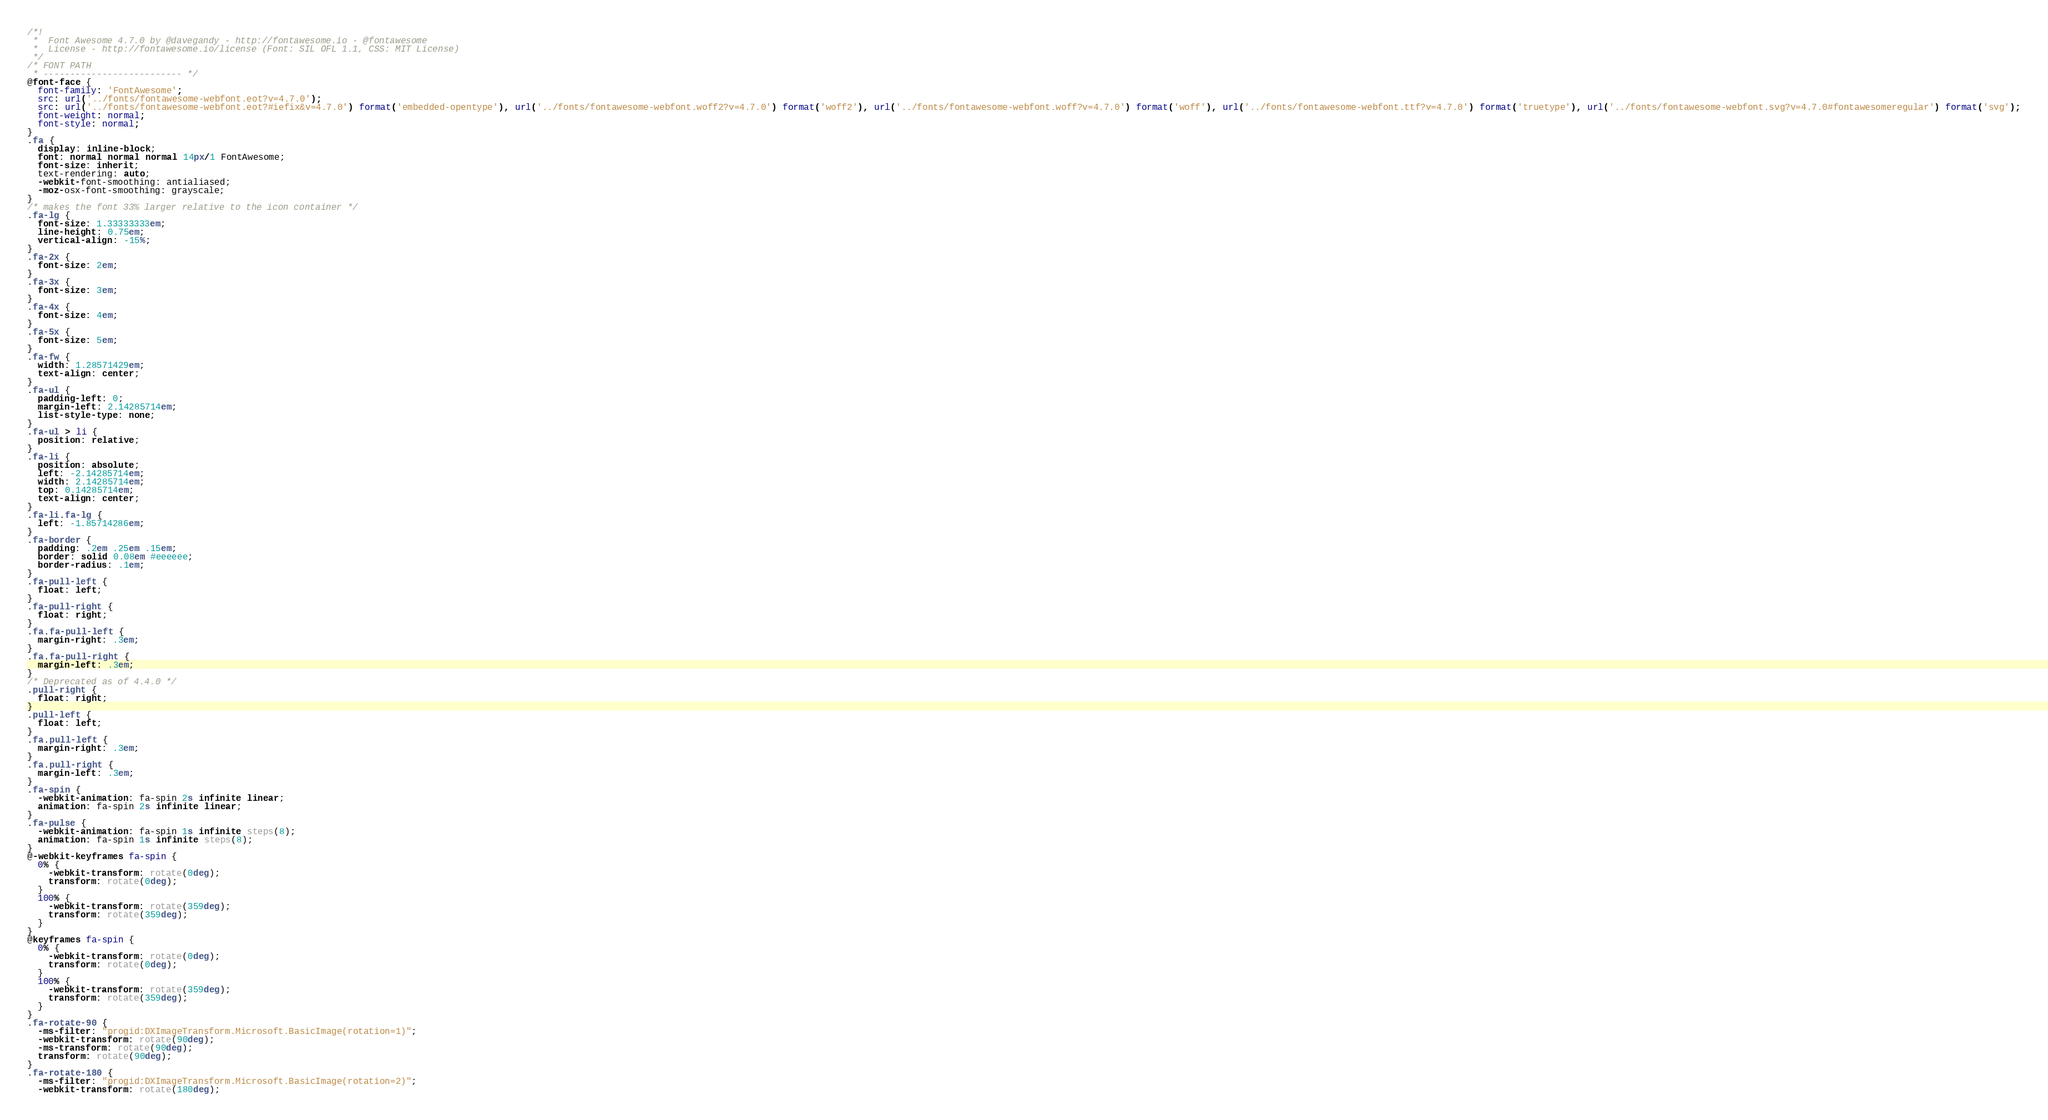<code> <loc_0><loc_0><loc_500><loc_500><_CSS_>/*!
 *  Font Awesome 4.7.0 by @davegandy - http://fontawesome.io - @fontawesome
 *  License - http://fontawesome.io/license (Font: SIL OFL 1.1, CSS: MIT License)
 */
/* FONT PATH
 * -------------------------- */
@font-face {
  font-family: 'FontAwesome';
  src: url('../fonts/fontawesome-webfont.eot?v=4.7.0');
  src: url('../fonts/fontawesome-webfont.eot?#iefix&v=4.7.0') format('embedded-opentype'), url('../fonts/fontawesome-webfont.woff2?v=4.7.0') format('woff2'), url('../fonts/fontawesome-webfont.woff?v=4.7.0') format('woff'), url('../fonts/fontawesome-webfont.ttf?v=4.7.0') format('truetype'), url('../fonts/fontawesome-webfont.svg?v=4.7.0#fontawesomeregular') format('svg');
  font-weight: normal;
  font-style: normal;
}
.fa {
  display: inline-block;
  font: normal normal normal 14px/1 FontAwesome;
  font-size: inherit;
  text-rendering: auto;
  -webkit-font-smoothing: antialiased;
  -moz-osx-font-smoothing: grayscale;
}
/* makes the font 33% larger relative to the icon container */
.fa-lg {
  font-size: 1.33333333em;
  line-height: 0.75em;
  vertical-align: -15%;
}
.fa-2x {
  font-size: 2em;
}
.fa-3x {
  font-size: 3em;
}
.fa-4x {
  font-size: 4em;
}
.fa-5x {
  font-size: 5em;
}
.fa-fw {
  width: 1.28571429em;
  text-align: center;
}
.fa-ul {
  padding-left: 0;
  margin-left: 2.14285714em;
  list-style-type: none;
}
.fa-ul > li {
  position: relative;
}
.fa-li {
  position: absolute;
  left: -2.14285714em;
  width: 2.14285714em;
  top: 0.14285714em;
  text-align: center;
}
.fa-li.fa-lg {
  left: -1.85714286em;
}
.fa-border {
  padding: .2em .25em .15em;
  border: solid 0.08em #eeeeee;
  border-radius: .1em;
}
.fa-pull-left {
  float: left;
}
.fa-pull-right {
  float: right;
}
.fa.fa-pull-left {
  margin-right: .3em;
}
.fa.fa-pull-right {
  margin-left: .3em;
}
/* Deprecated as of 4.4.0 */
.pull-right {
  float: right;
}
.pull-left {
  float: left;
}
.fa.pull-left {
  margin-right: .3em;
}
.fa.pull-right {
  margin-left: .3em;
}
.fa-spin {
  -webkit-animation: fa-spin 2s infinite linear;
  animation: fa-spin 2s infinite linear;
}
.fa-pulse {
  -webkit-animation: fa-spin 1s infinite steps(8);
  animation: fa-spin 1s infinite steps(8);
}
@-webkit-keyframes fa-spin {
  0% {
    -webkit-transform: rotate(0deg);
    transform: rotate(0deg);
  }
  100% {
    -webkit-transform: rotate(359deg);
    transform: rotate(359deg);
  }
}
@keyframes fa-spin {
  0% {
    -webkit-transform: rotate(0deg);
    transform: rotate(0deg);
  }
  100% {
    -webkit-transform: rotate(359deg);
    transform: rotate(359deg);
  }
}
.fa-rotate-90 {
  -ms-filter: "progid:DXImageTransform.Microsoft.BasicImage(rotation=1)";
  -webkit-transform: rotate(90deg);
  -ms-transform: rotate(90deg);
  transform: rotate(90deg);
}
.fa-rotate-180 {
  -ms-filter: "progid:DXImageTransform.Microsoft.BasicImage(rotation=2)";
  -webkit-transform: rotate(180deg);</code> 